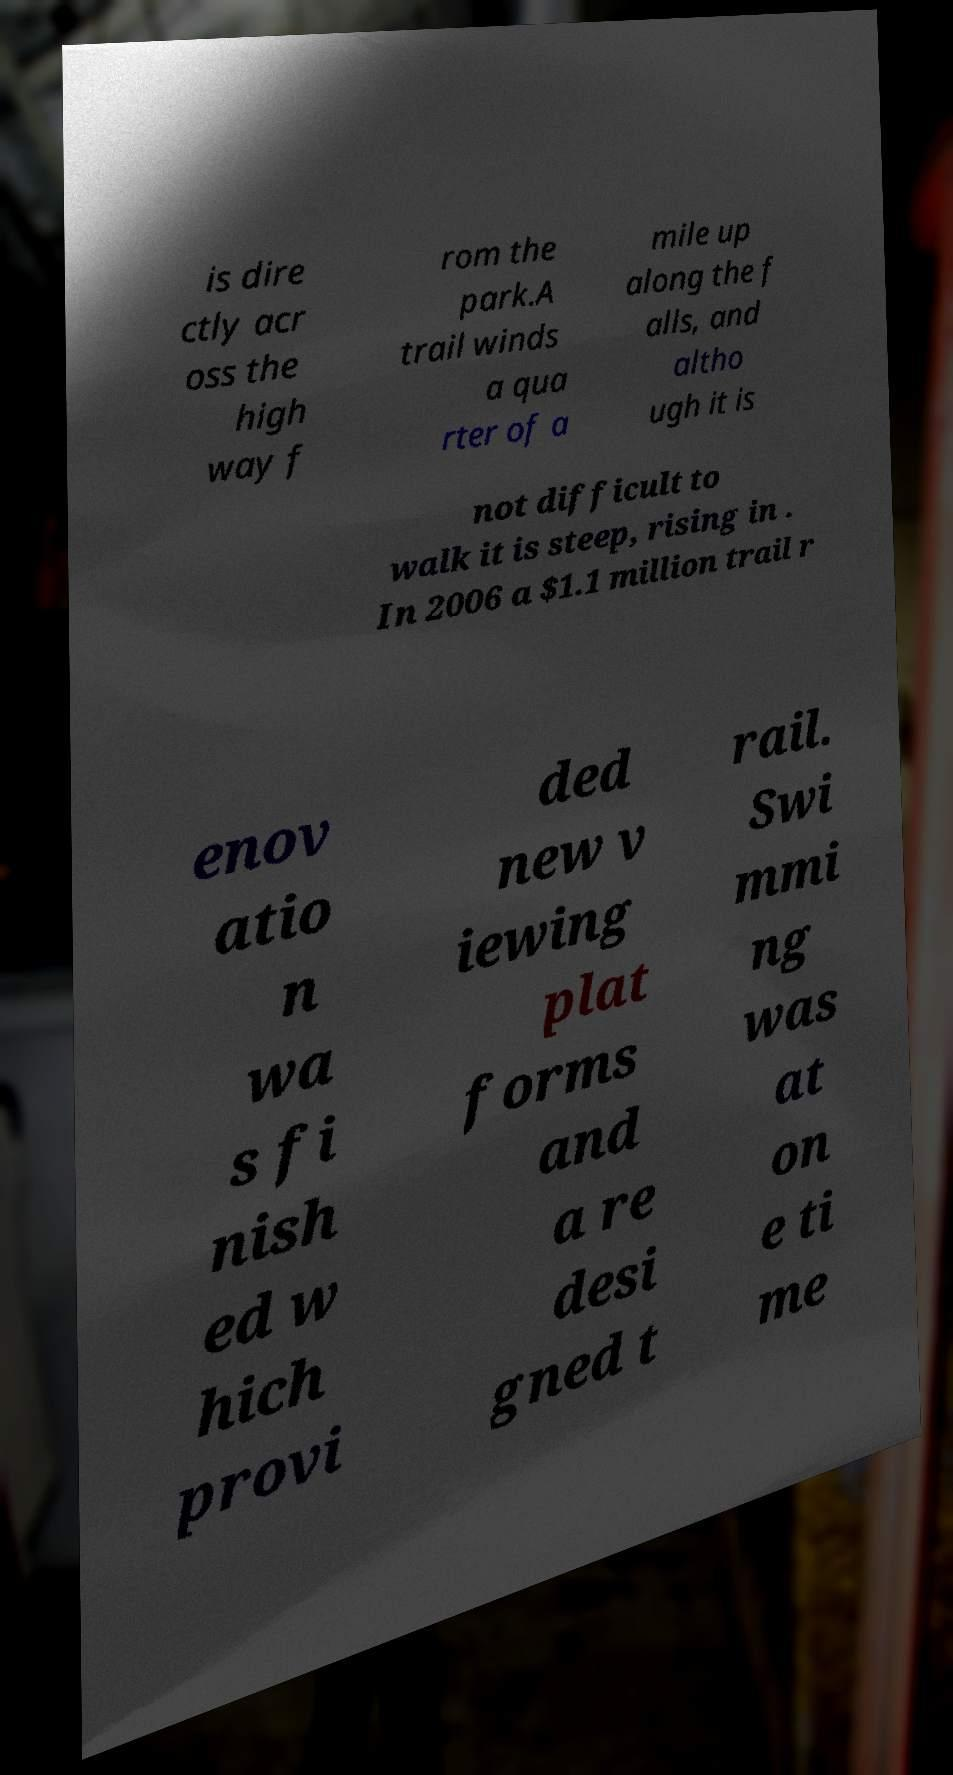Can you read and provide the text displayed in the image?This photo seems to have some interesting text. Can you extract and type it out for me? is dire ctly acr oss the high way f rom the park.A trail winds a qua rter of a mile up along the f alls, and altho ugh it is not difficult to walk it is steep, rising in . In 2006 a $1.1 million trail r enov atio n wa s fi nish ed w hich provi ded new v iewing plat forms and a re desi gned t rail. Swi mmi ng was at on e ti me 